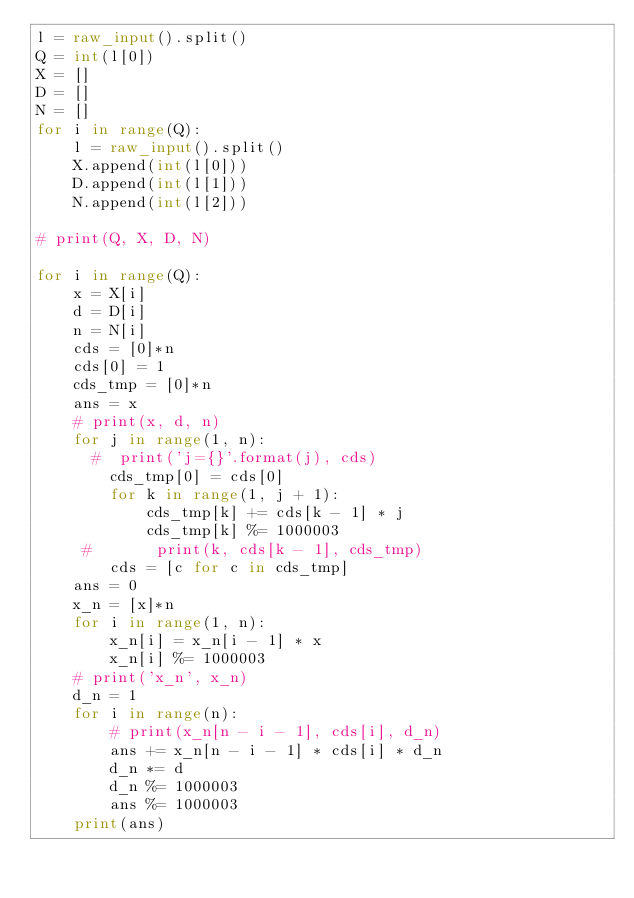<code> <loc_0><loc_0><loc_500><loc_500><_Python_>l = raw_input().split()
Q = int(l[0])
X = []
D = []
N = []
for i in range(Q):
    l = raw_input().split()
    X.append(int(l[0]))
    D.append(int(l[1]))
    N.append(int(l[2]))

# print(Q, X, D, N)

for i in range(Q):
    x = X[i]
    d = D[i]
    n = N[i]
    cds = [0]*n
    cds[0] = 1
    cds_tmp = [0]*n
    ans = x
    # print(x, d, n)
    for j in range(1, n):
      #  print('j={}'.format(j), cds)
        cds_tmp[0] = cds[0]
        for k in range(1, j + 1):
            cds_tmp[k] += cds[k - 1] * j
            cds_tmp[k] %= 1000003
     #       print(k, cds[k - 1], cds_tmp)
        cds = [c for c in cds_tmp]
    ans = 0
    x_n = [x]*n
    for i in range(1, n):
        x_n[i] = x_n[i - 1] * x
        x_n[i] %= 1000003
    # print('x_n', x_n)
    d_n = 1
    for i in range(n):
        # print(x_n[n - i - 1], cds[i], d_n)
        ans += x_n[n - i - 1] * cds[i] * d_n
        d_n *= d
        d_n %= 1000003
        ans %= 1000003
    print(ans)
</code> 